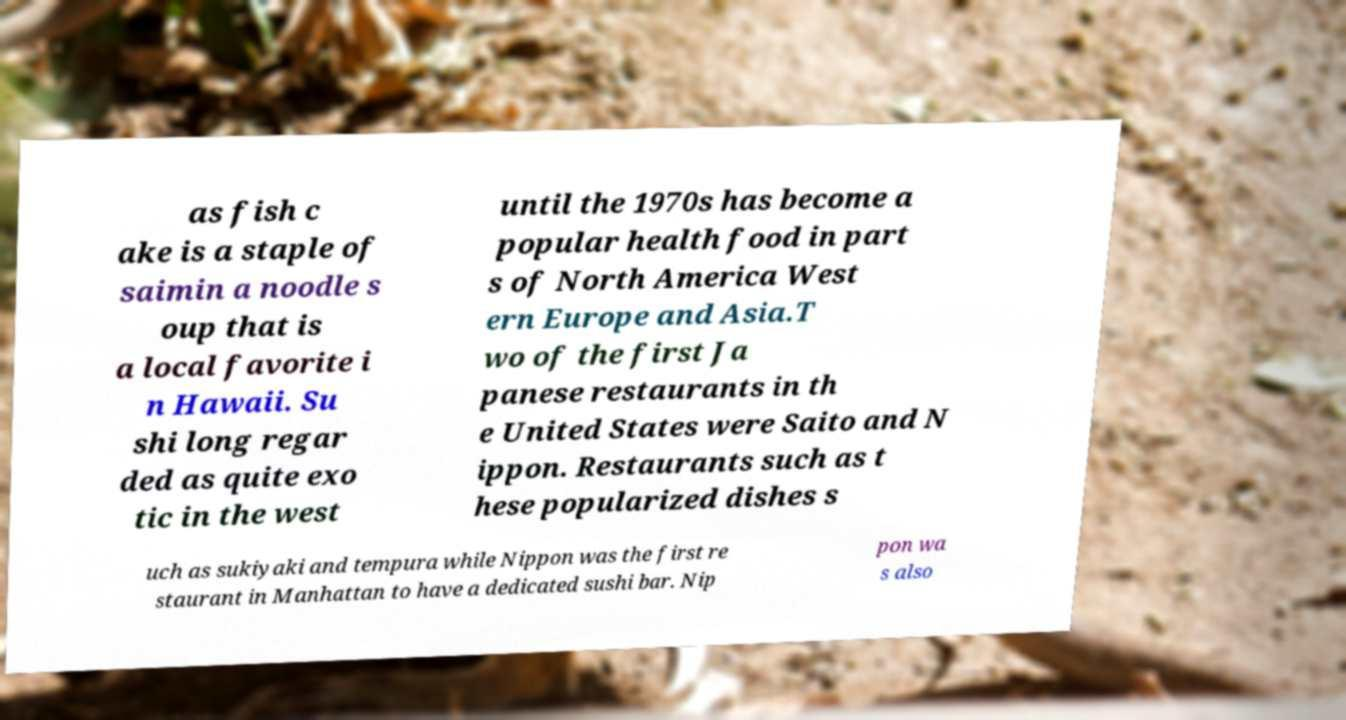Please read and relay the text visible in this image. What does it say? as fish c ake is a staple of saimin a noodle s oup that is a local favorite i n Hawaii. Su shi long regar ded as quite exo tic in the west until the 1970s has become a popular health food in part s of North America West ern Europe and Asia.T wo of the first Ja panese restaurants in th e United States were Saito and N ippon. Restaurants such as t hese popularized dishes s uch as sukiyaki and tempura while Nippon was the first re staurant in Manhattan to have a dedicated sushi bar. Nip pon wa s also 